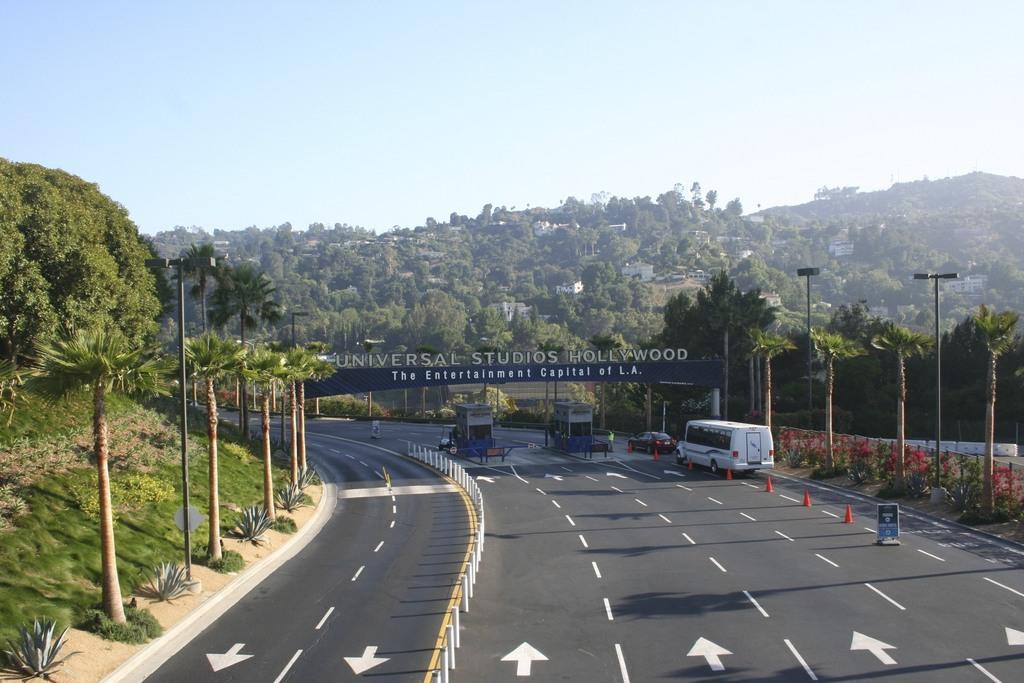Please provide a concise description of this image. In this image we can see the vehicles on the road. And we can see the traffic cones. And we can see the metal fence. And we can see the grass and trees. And we can see a few houses. And we can see the sky. And we can see a board with some text on it. And we can see the lights. 